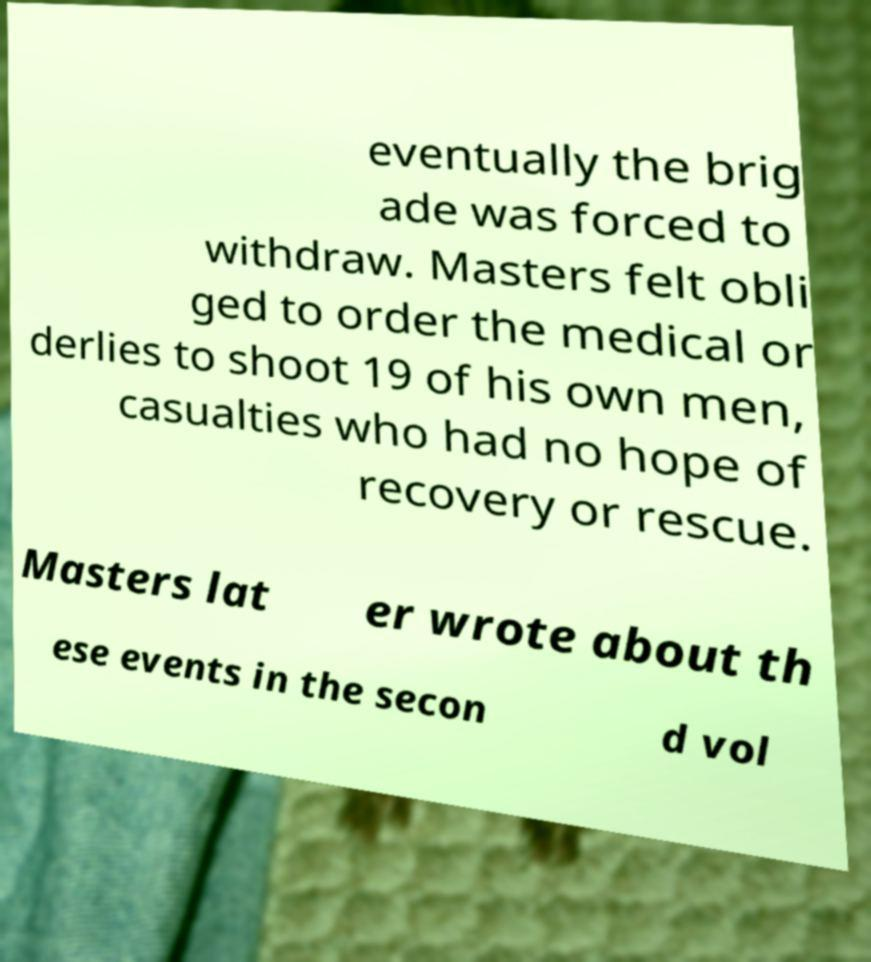Can you read and provide the text displayed in the image?This photo seems to have some interesting text. Can you extract and type it out for me? eventually the brig ade was forced to withdraw. Masters felt obli ged to order the medical or derlies to shoot 19 of his own men, casualties who had no hope of recovery or rescue. Masters lat er wrote about th ese events in the secon d vol 